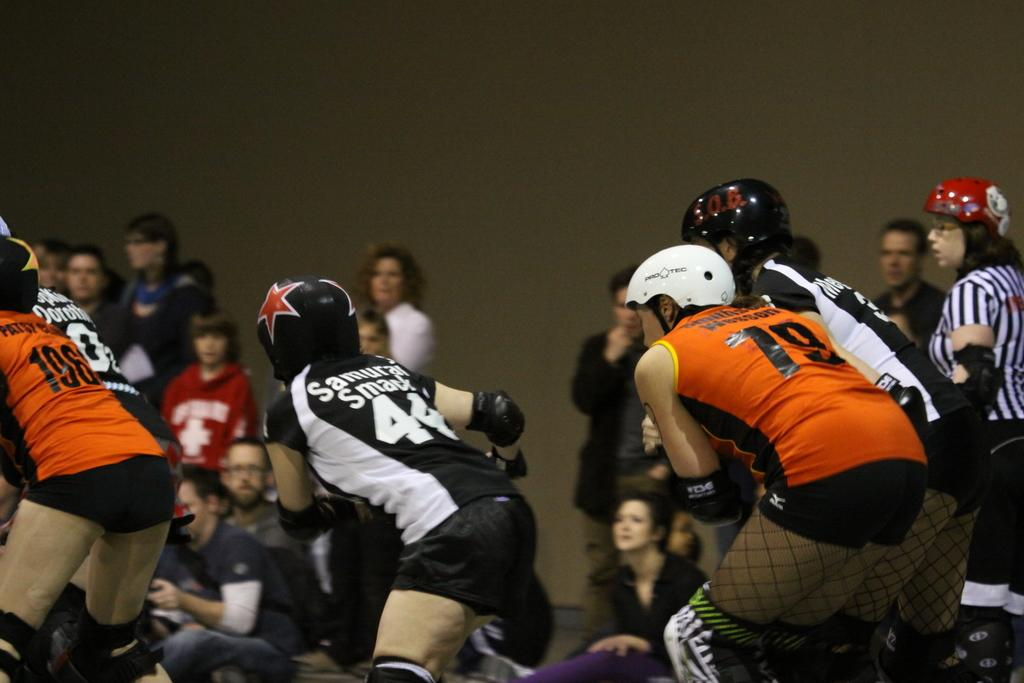How many girls are present in the image? There are four girls in the image. What colors are the t-shirts worn by the girls? The girls are wearing orange, white, and black t-shirts. What protective gear are the girls wearing? The girls are wearing helmets. What activity are the girls engaged in? The girls are playing a game. Can you describe the people in the background of the image? There is a group of audience in the background, and they are watching the game. Is there a volcano erupting in the background of the image? No, there is no volcano present in the image. What type of feast is being prepared by the girls in the image? The girls are not preparing a feast in the image; they are playing a game. 